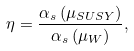<formula> <loc_0><loc_0><loc_500><loc_500>\eta = \frac { \alpha _ { s } \left ( \mu _ { S U S Y } \right ) } { \alpha _ { s } \left ( \mu _ { W } \right ) } ,</formula> 